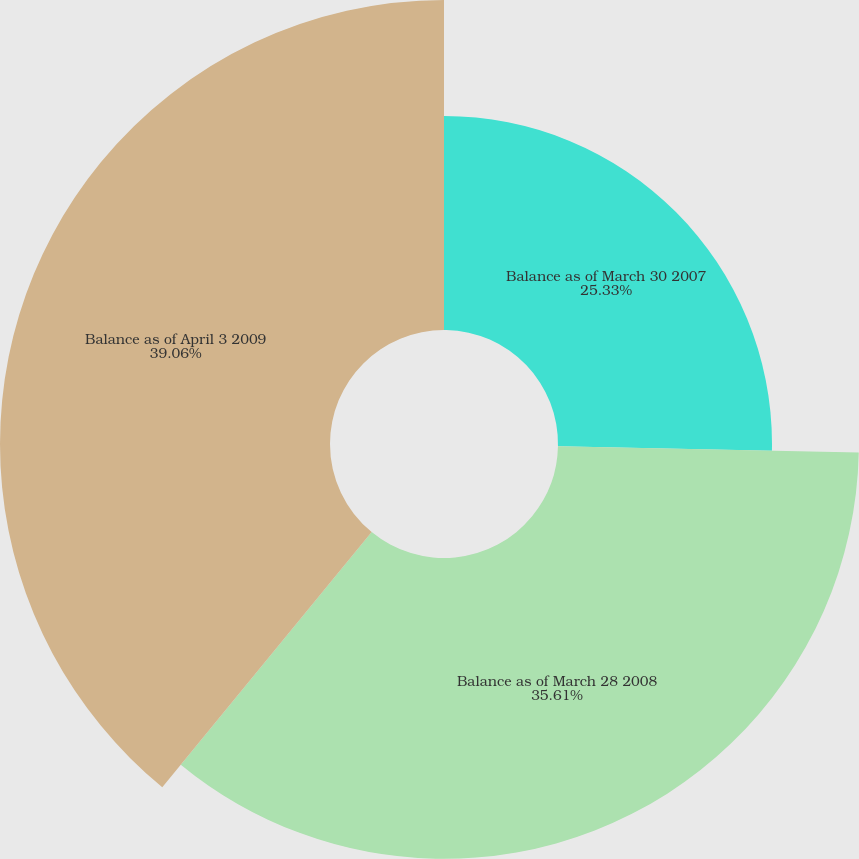<chart> <loc_0><loc_0><loc_500><loc_500><pie_chart><fcel>Balance as of March 30 2007<fcel>Balance as of March 28 2008<fcel>Balance as of April 3 2009<nl><fcel>25.33%<fcel>35.61%<fcel>39.06%<nl></chart> 